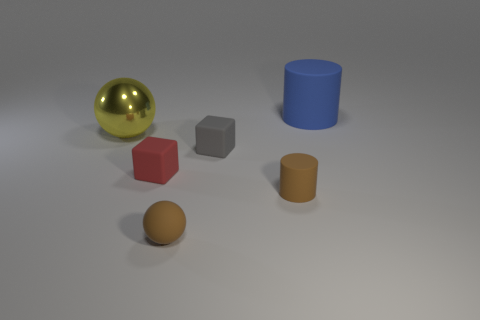There is a tiny matte object in front of the cylinder that is in front of the yellow metallic thing; what is its color?
Your answer should be compact. Brown. Is the yellow ball the same size as the matte ball?
Keep it short and to the point. No. Is the material of the big thing on the right side of the gray object the same as the tiny object left of the small rubber sphere?
Provide a short and direct response. Yes. What shape is the tiny brown thing that is to the right of the small brown object to the left of the tiny rubber cylinder in front of the large rubber object?
Provide a succinct answer. Cylinder. Is the number of small cylinders greater than the number of big green objects?
Make the answer very short. Yes. Are any tiny blue rubber blocks visible?
Offer a terse response. No. What number of objects are either balls that are behind the brown ball or small blocks on the right side of the small brown matte sphere?
Your answer should be very brief. 2. Is the tiny matte ball the same color as the small cylinder?
Your response must be concise. Yes. Are there fewer yellow shiny balls than big brown rubber balls?
Your answer should be very brief. No. Are there any blue objects to the right of the yellow shiny object?
Ensure brevity in your answer.  Yes. 